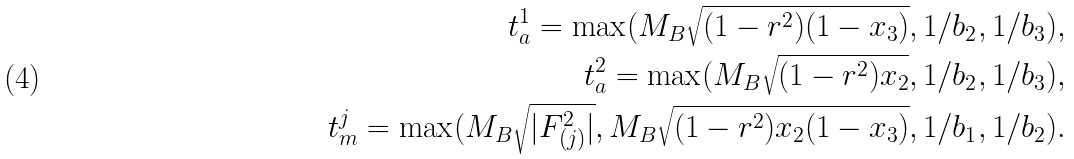Convert formula to latex. <formula><loc_0><loc_0><loc_500><loc_500>t _ { a } ^ { 1 } = \max ( M _ { B } \sqrt { ( 1 - r ^ { 2 } ) ( 1 - x _ { 3 } ) } , 1 / b _ { 2 } , 1 / b _ { 3 } ) , \\ t _ { a } ^ { 2 } = \max ( M _ { B } \sqrt { ( 1 - r ^ { 2 } ) x _ { 2 } } , 1 / b _ { 2 } , 1 / b _ { 3 } ) , \\ t _ { m } ^ { j } = \max ( M _ { B } \sqrt { | F ^ { 2 } _ { ( j ) } | } , M _ { B } \sqrt { ( 1 - r ^ { 2 } ) x _ { 2 } ( 1 - x _ { 3 } ) } , 1 / b _ { 1 } , 1 / b _ { 2 } ) .</formula> 